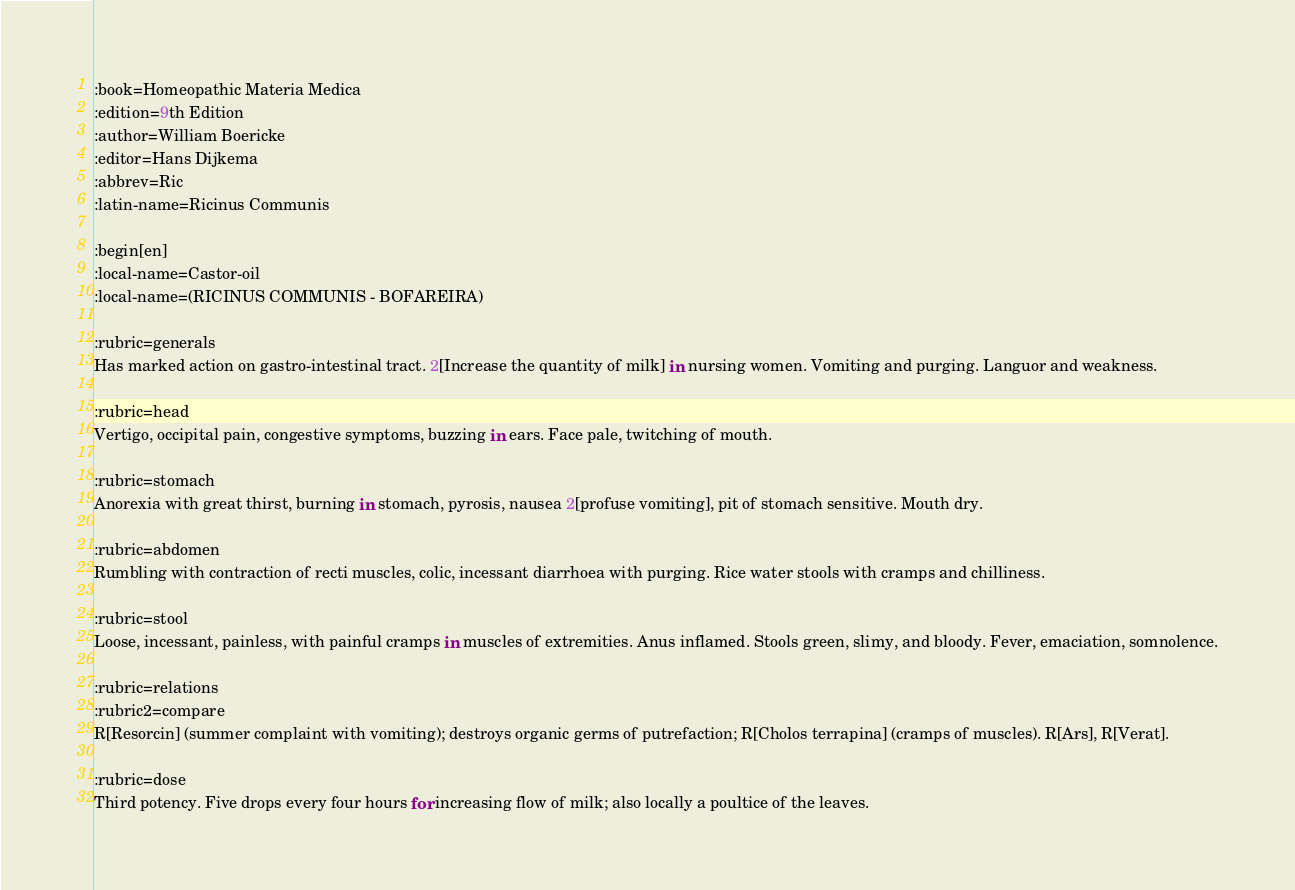<code> <loc_0><loc_0><loc_500><loc_500><_ObjectiveC_>:book=Homeopathic Materia Medica
:edition=9th Edition
:author=William Boericke
:editor=Hans Dijkema
:abbrev=Ric
:latin-name=Ricinus Communis

:begin[en]
:local-name=Castor-oil
:local-name=(RICINUS COMMUNIS - BOFAREIRA)

:rubric=generals
Has marked action on gastro-intestinal tract. 2[Increase the quantity of milk] in nursing women. Vomiting and purging. Languor and weakness.

:rubric=head
Vertigo, occipital pain, congestive symptoms, buzzing in ears. Face pale, twitching of mouth.

:rubric=stomach
Anorexia with great thirst, burning in stomach, pyrosis, nausea 2[profuse vomiting], pit of stomach sensitive. Mouth dry.

:rubric=abdomen
Rumbling with contraction of recti muscles, colic, incessant diarrhoea with purging. Rice water stools with cramps and chilliness.

:rubric=stool
Loose, incessant, painless, with painful cramps in muscles of extremities. Anus inflamed. Stools green, slimy, and bloody. Fever, emaciation, somnolence.

:rubric=relations
:rubric2=compare
R[Resorcin] (summer complaint with vomiting); destroys organic germs of putrefaction; R[Cholos terrapina] (cramps of muscles). R[Ars], R[Verat].

:rubric=dose
Third potency. Five drops every four hours for increasing flow of milk; also locally a poultice of the leaves.

</code> 